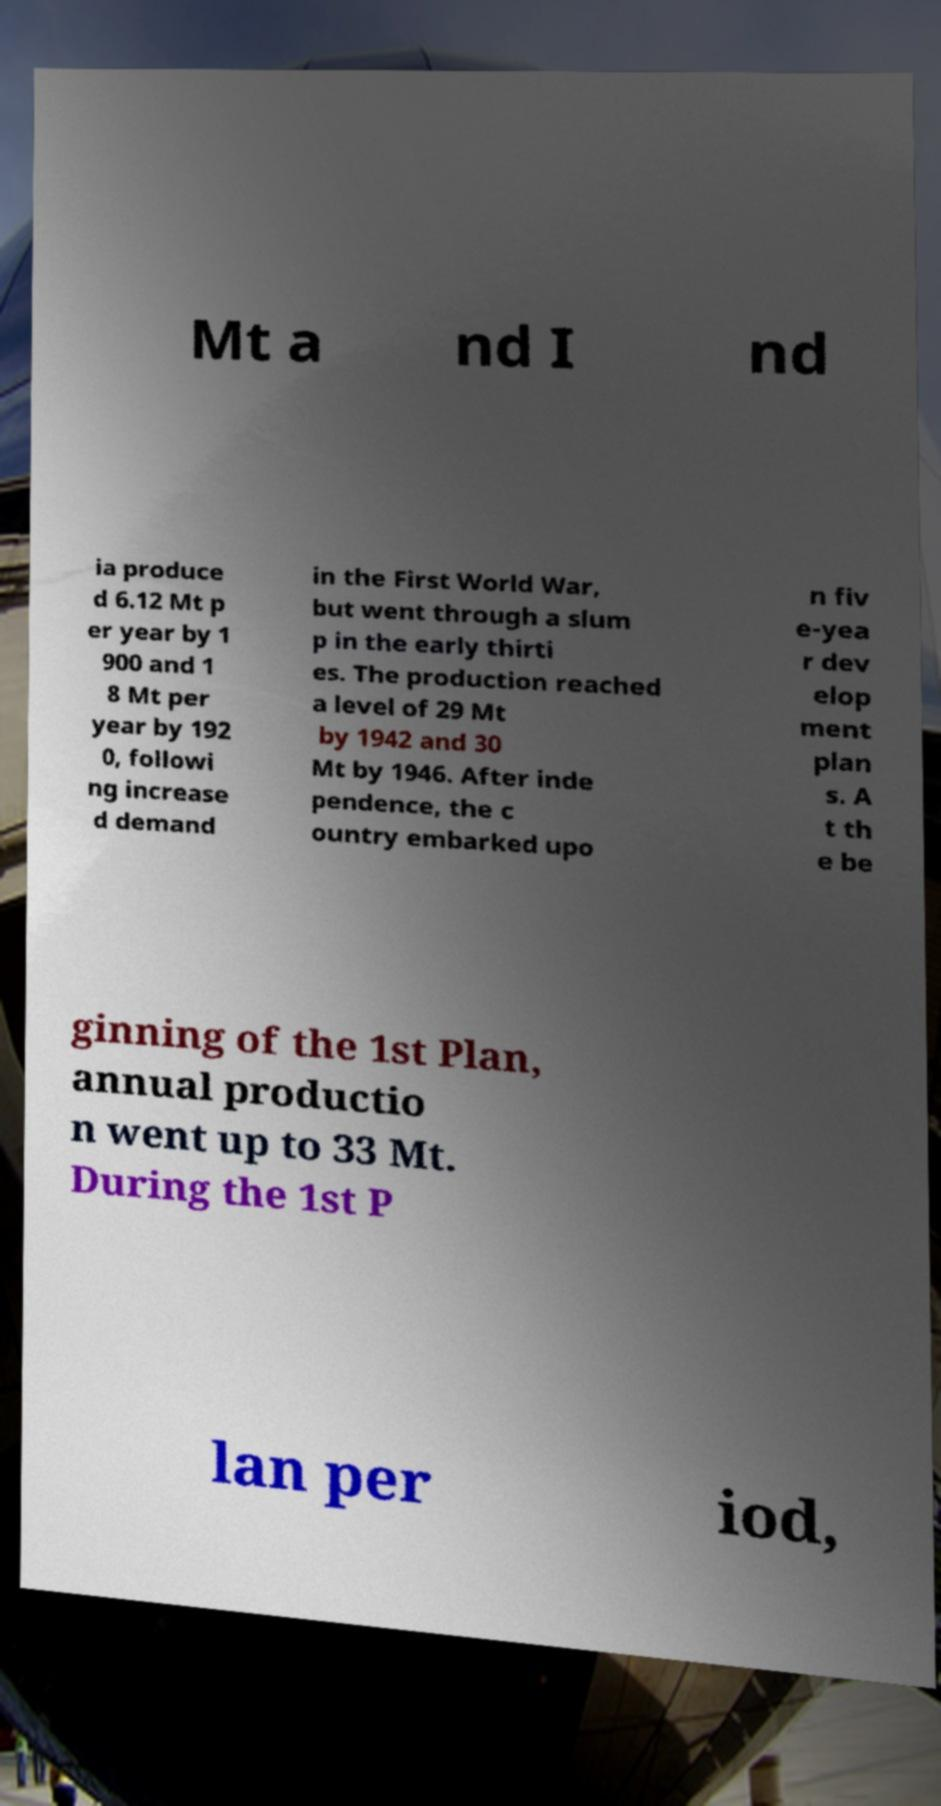What messages or text are displayed in this image? I need them in a readable, typed format. Mt a nd I nd ia produce d 6.12 Mt p er year by 1 900 and 1 8 Mt per year by 192 0, followi ng increase d demand in the First World War, but went through a slum p in the early thirti es. The production reached a level of 29 Mt by 1942 and 30 Mt by 1946. After inde pendence, the c ountry embarked upo n fiv e-yea r dev elop ment plan s. A t th e be ginning of the 1st Plan, annual productio n went up to 33 Mt. During the 1st P lan per iod, 